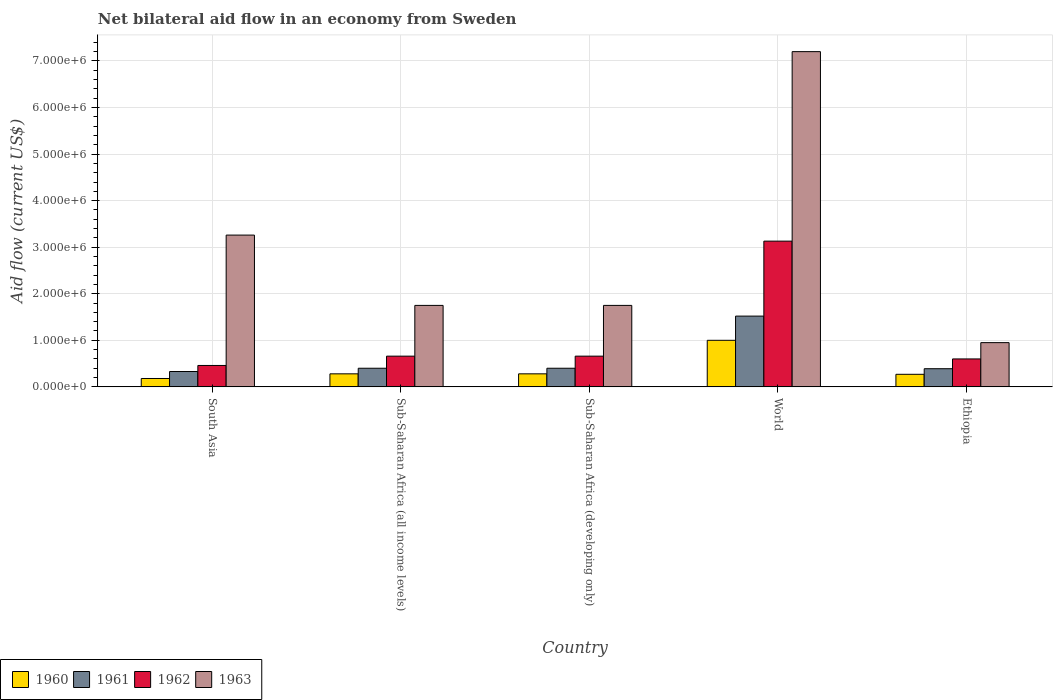How many different coloured bars are there?
Ensure brevity in your answer.  4. How many bars are there on the 2nd tick from the left?
Your response must be concise. 4. How many bars are there on the 5th tick from the right?
Give a very brief answer. 4. What is the label of the 5th group of bars from the left?
Keep it short and to the point. Ethiopia. What is the net bilateral aid flow in 1963 in South Asia?
Your answer should be compact. 3.26e+06. Across all countries, what is the maximum net bilateral aid flow in 1961?
Your answer should be compact. 1.52e+06. In which country was the net bilateral aid flow in 1960 maximum?
Provide a short and direct response. World. In which country was the net bilateral aid flow in 1960 minimum?
Offer a terse response. South Asia. What is the total net bilateral aid flow in 1961 in the graph?
Provide a succinct answer. 3.04e+06. What is the difference between the net bilateral aid flow in 1963 in Ethiopia and that in World?
Ensure brevity in your answer.  -6.25e+06. What is the average net bilateral aid flow in 1963 per country?
Make the answer very short. 2.98e+06. In how many countries, is the net bilateral aid flow in 1963 greater than 3600000 US$?
Your answer should be very brief. 1. What is the ratio of the net bilateral aid flow in 1961 in South Asia to that in World?
Offer a terse response. 0.22. Is the net bilateral aid flow in 1961 in Ethiopia less than that in South Asia?
Offer a terse response. No. Is the difference between the net bilateral aid flow in 1962 in Sub-Saharan Africa (developing only) and World greater than the difference between the net bilateral aid flow in 1960 in Sub-Saharan Africa (developing only) and World?
Ensure brevity in your answer.  No. What is the difference between the highest and the second highest net bilateral aid flow in 1960?
Provide a succinct answer. 7.20e+05. What is the difference between the highest and the lowest net bilateral aid flow in 1962?
Your answer should be very brief. 2.67e+06. How many countries are there in the graph?
Give a very brief answer. 5. What is the difference between two consecutive major ticks on the Y-axis?
Your answer should be very brief. 1.00e+06. Where does the legend appear in the graph?
Keep it short and to the point. Bottom left. How many legend labels are there?
Provide a succinct answer. 4. What is the title of the graph?
Provide a succinct answer. Net bilateral aid flow in an economy from Sweden. Does "1988" appear as one of the legend labels in the graph?
Your response must be concise. No. What is the label or title of the Y-axis?
Offer a terse response. Aid flow (current US$). What is the Aid flow (current US$) in 1960 in South Asia?
Offer a terse response. 1.80e+05. What is the Aid flow (current US$) of 1961 in South Asia?
Provide a succinct answer. 3.30e+05. What is the Aid flow (current US$) of 1962 in South Asia?
Your answer should be compact. 4.60e+05. What is the Aid flow (current US$) of 1963 in South Asia?
Make the answer very short. 3.26e+06. What is the Aid flow (current US$) of 1960 in Sub-Saharan Africa (all income levels)?
Your response must be concise. 2.80e+05. What is the Aid flow (current US$) in 1961 in Sub-Saharan Africa (all income levels)?
Your response must be concise. 4.00e+05. What is the Aid flow (current US$) in 1962 in Sub-Saharan Africa (all income levels)?
Offer a terse response. 6.60e+05. What is the Aid flow (current US$) of 1963 in Sub-Saharan Africa (all income levels)?
Provide a short and direct response. 1.75e+06. What is the Aid flow (current US$) in 1960 in Sub-Saharan Africa (developing only)?
Provide a short and direct response. 2.80e+05. What is the Aid flow (current US$) of 1962 in Sub-Saharan Africa (developing only)?
Your response must be concise. 6.60e+05. What is the Aid flow (current US$) of 1963 in Sub-Saharan Africa (developing only)?
Provide a succinct answer. 1.75e+06. What is the Aid flow (current US$) in 1961 in World?
Give a very brief answer. 1.52e+06. What is the Aid flow (current US$) in 1962 in World?
Your response must be concise. 3.13e+06. What is the Aid flow (current US$) of 1963 in World?
Keep it short and to the point. 7.20e+06. What is the Aid flow (current US$) in 1963 in Ethiopia?
Keep it short and to the point. 9.50e+05. Across all countries, what is the maximum Aid flow (current US$) of 1960?
Your answer should be compact. 1.00e+06. Across all countries, what is the maximum Aid flow (current US$) in 1961?
Give a very brief answer. 1.52e+06. Across all countries, what is the maximum Aid flow (current US$) of 1962?
Offer a very short reply. 3.13e+06. Across all countries, what is the maximum Aid flow (current US$) in 1963?
Give a very brief answer. 7.20e+06. Across all countries, what is the minimum Aid flow (current US$) of 1960?
Give a very brief answer. 1.80e+05. Across all countries, what is the minimum Aid flow (current US$) in 1962?
Make the answer very short. 4.60e+05. Across all countries, what is the minimum Aid flow (current US$) in 1963?
Your answer should be very brief. 9.50e+05. What is the total Aid flow (current US$) of 1960 in the graph?
Ensure brevity in your answer.  2.01e+06. What is the total Aid flow (current US$) in 1961 in the graph?
Keep it short and to the point. 3.04e+06. What is the total Aid flow (current US$) in 1962 in the graph?
Offer a terse response. 5.51e+06. What is the total Aid flow (current US$) in 1963 in the graph?
Ensure brevity in your answer.  1.49e+07. What is the difference between the Aid flow (current US$) in 1960 in South Asia and that in Sub-Saharan Africa (all income levels)?
Your answer should be compact. -1.00e+05. What is the difference between the Aid flow (current US$) of 1963 in South Asia and that in Sub-Saharan Africa (all income levels)?
Give a very brief answer. 1.51e+06. What is the difference between the Aid flow (current US$) in 1961 in South Asia and that in Sub-Saharan Africa (developing only)?
Give a very brief answer. -7.00e+04. What is the difference between the Aid flow (current US$) of 1963 in South Asia and that in Sub-Saharan Africa (developing only)?
Your response must be concise. 1.51e+06. What is the difference between the Aid flow (current US$) of 1960 in South Asia and that in World?
Provide a succinct answer. -8.20e+05. What is the difference between the Aid flow (current US$) of 1961 in South Asia and that in World?
Offer a terse response. -1.19e+06. What is the difference between the Aid flow (current US$) of 1962 in South Asia and that in World?
Give a very brief answer. -2.67e+06. What is the difference between the Aid flow (current US$) in 1963 in South Asia and that in World?
Offer a terse response. -3.94e+06. What is the difference between the Aid flow (current US$) of 1960 in South Asia and that in Ethiopia?
Your answer should be compact. -9.00e+04. What is the difference between the Aid flow (current US$) in 1962 in South Asia and that in Ethiopia?
Provide a succinct answer. -1.40e+05. What is the difference between the Aid flow (current US$) of 1963 in South Asia and that in Ethiopia?
Keep it short and to the point. 2.31e+06. What is the difference between the Aid flow (current US$) in 1960 in Sub-Saharan Africa (all income levels) and that in World?
Offer a very short reply. -7.20e+05. What is the difference between the Aid flow (current US$) of 1961 in Sub-Saharan Africa (all income levels) and that in World?
Ensure brevity in your answer.  -1.12e+06. What is the difference between the Aid flow (current US$) of 1962 in Sub-Saharan Africa (all income levels) and that in World?
Offer a very short reply. -2.47e+06. What is the difference between the Aid flow (current US$) in 1963 in Sub-Saharan Africa (all income levels) and that in World?
Offer a terse response. -5.45e+06. What is the difference between the Aid flow (current US$) of 1960 in Sub-Saharan Africa (all income levels) and that in Ethiopia?
Make the answer very short. 10000. What is the difference between the Aid flow (current US$) in 1962 in Sub-Saharan Africa (all income levels) and that in Ethiopia?
Offer a very short reply. 6.00e+04. What is the difference between the Aid flow (current US$) of 1963 in Sub-Saharan Africa (all income levels) and that in Ethiopia?
Offer a terse response. 8.00e+05. What is the difference between the Aid flow (current US$) of 1960 in Sub-Saharan Africa (developing only) and that in World?
Ensure brevity in your answer.  -7.20e+05. What is the difference between the Aid flow (current US$) in 1961 in Sub-Saharan Africa (developing only) and that in World?
Your response must be concise. -1.12e+06. What is the difference between the Aid flow (current US$) of 1962 in Sub-Saharan Africa (developing only) and that in World?
Your answer should be very brief. -2.47e+06. What is the difference between the Aid flow (current US$) in 1963 in Sub-Saharan Africa (developing only) and that in World?
Your answer should be very brief. -5.45e+06. What is the difference between the Aid flow (current US$) of 1960 in Sub-Saharan Africa (developing only) and that in Ethiopia?
Provide a succinct answer. 10000. What is the difference between the Aid flow (current US$) in 1962 in Sub-Saharan Africa (developing only) and that in Ethiopia?
Provide a short and direct response. 6.00e+04. What is the difference between the Aid flow (current US$) of 1960 in World and that in Ethiopia?
Offer a very short reply. 7.30e+05. What is the difference between the Aid flow (current US$) in 1961 in World and that in Ethiopia?
Ensure brevity in your answer.  1.13e+06. What is the difference between the Aid flow (current US$) in 1962 in World and that in Ethiopia?
Your response must be concise. 2.53e+06. What is the difference between the Aid flow (current US$) in 1963 in World and that in Ethiopia?
Offer a terse response. 6.25e+06. What is the difference between the Aid flow (current US$) in 1960 in South Asia and the Aid flow (current US$) in 1961 in Sub-Saharan Africa (all income levels)?
Provide a succinct answer. -2.20e+05. What is the difference between the Aid flow (current US$) in 1960 in South Asia and the Aid flow (current US$) in 1962 in Sub-Saharan Africa (all income levels)?
Your answer should be very brief. -4.80e+05. What is the difference between the Aid flow (current US$) in 1960 in South Asia and the Aid flow (current US$) in 1963 in Sub-Saharan Africa (all income levels)?
Your response must be concise. -1.57e+06. What is the difference between the Aid flow (current US$) in 1961 in South Asia and the Aid flow (current US$) in 1962 in Sub-Saharan Africa (all income levels)?
Your answer should be compact. -3.30e+05. What is the difference between the Aid flow (current US$) in 1961 in South Asia and the Aid flow (current US$) in 1963 in Sub-Saharan Africa (all income levels)?
Offer a terse response. -1.42e+06. What is the difference between the Aid flow (current US$) in 1962 in South Asia and the Aid flow (current US$) in 1963 in Sub-Saharan Africa (all income levels)?
Your response must be concise. -1.29e+06. What is the difference between the Aid flow (current US$) of 1960 in South Asia and the Aid flow (current US$) of 1961 in Sub-Saharan Africa (developing only)?
Your answer should be compact. -2.20e+05. What is the difference between the Aid flow (current US$) in 1960 in South Asia and the Aid flow (current US$) in 1962 in Sub-Saharan Africa (developing only)?
Your response must be concise. -4.80e+05. What is the difference between the Aid flow (current US$) of 1960 in South Asia and the Aid flow (current US$) of 1963 in Sub-Saharan Africa (developing only)?
Make the answer very short. -1.57e+06. What is the difference between the Aid flow (current US$) in 1961 in South Asia and the Aid flow (current US$) in 1962 in Sub-Saharan Africa (developing only)?
Your answer should be very brief. -3.30e+05. What is the difference between the Aid flow (current US$) of 1961 in South Asia and the Aid flow (current US$) of 1963 in Sub-Saharan Africa (developing only)?
Offer a terse response. -1.42e+06. What is the difference between the Aid flow (current US$) of 1962 in South Asia and the Aid flow (current US$) of 1963 in Sub-Saharan Africa (developing only)?
Provide a succinct answer. -1.29e+06. What is the difference between the Aid flow (current US$) in 1960 in South Asia and the Aid flow (current US$) in 1961 in World?
Offer a very short reply. -1.34e+06. What is the difference between the Aid flow (current US$) of 1960 in South Asia and the Aid flow (current US$) of 1962 in World?
Your answer should be very brief. -2.95e+06. What is the difference between the Aid flow (current US$) in 1960 in South Asia and the Aid flow (current US$) in 1963 in World?
Provide a succinct answer. -7.02e+06. What is the difference between the Aid flow (current US$) of 1961 in South Asia and the Aid flow (current US$) of 1962 in World?
Your answer should be very brief. -2.80e+06. What is the difference between the Aid flow (current US$) in 1961 in South Asia and the Aid flow (current US$) in 1963 in World?
Provide a succinct answer. -6.87e+06. What is the difference between the Aid flow (current US$) of 1962 in South Asia and the Aid flow (current US$) of 1963 in World?
Provide a short and direct response. -6.74e+06. What is the difference between the Aid flow (current US$) in 1960 in South Asia and the Aid flow (current US$) in 1961 in Ethiopia?
Your answer should be very brief. -2.10e+05. What is the difference between the Aid flow (current US$) in 1960 in South Asia and the Aid flow (current US$) in 1962 in Ethiopia?
Provide a succinct answer. -4.20e+05. What is the difference between the Aid flow (current US$) in 1960 in South Asia and the Aid flow (current US$) in 1963 in Ethiopia?
Keep it short and to the point. -7.70e+05. What is the difference between the Aid flow (current US$) of 1961 in South Asia and the Aid flow (current US$) of 1962 in Ethiopia?
Keep it short and to the point. -2.70e+05. What is the difference between the Aid flow (current US$) in 1961 in South Asia and the Aid flow (current US$) in 1963 in Ethiopia?
Provide a short and direct response. -6.20e+05. What is the difference between the Aid flow (current US$) in 1962 in South Asia and the Aid flow (current US$) in 1963 in Ethiopia?
Provide a short and direct response. -4.90e+05. What is the difference between the Aid flow (current US$) of 1960 in Sub-Saharan Africa (all income levels) and the Aid flow (current US$) of 1962 in Sub-Saharan Africa (developing only)?
Ensure brevity in your answer.  -3.80e+05. What is the difference between the Aid flow (current US$) in 1960 in Sub-Saharan Africa (all income levels) and the Aid flow (current US$) in 1963 in Sub-Saharan Africa (developing only)?
Give a very brief answer. -1.47e+06. What is the difference between the Aid flow (current US$) in 1961 in Sub-Saharan Africa (all income levels) and the Aid flow (current US$) in 1962 in Sub-Saharan Africa (developing only)?
Offer a very short reply. -2.60e+05. What is the difference between the Aid flow (current US$) in 1961 in Sub-Saharan Africa (all income levels) and the Aid flow (current US$) in 1963 in Sub-Saharan Africa (developing only)?
Ensure brevity in your answer.  -1.35e+06. What is the difference between the Aid flow (current US$) of 1962 in Sub-Saharan Africa (all income levels) and the Aid flow (current US$) of 1963 in Sub-Saharan Africa (developing only)?
Give a very brief answer. -1.09e+06. What is the difference between the Aid flow (current US$) of 1960 in Sub-Saharan Africa (all income levels) and the Aid flow (current US$) of 1961 in World?
Offer a terse response. -1.24e+06. What is the difference between the Aid flow (current US$) in 1960 in Sub-Saharan Africa (all income levels) and the Aid flow (current US$) in 1962 in World?
Provide a succinct answer. -2.85e+06. What is the difference between the Aid flow (current US$) in 1960 in Sub-Saharan Africa (all income levels) and the Aid flow (current US$) in 1963 in World?
Offer a very short reply. -6.92e+06. What is the difference between the Aid flow (current US$) in 1961 in Sub-Saharan Africa (all income levels) and the Aid flow (current US$) in 1962 in World?
Provide a succinct answer. -2.73e+06. What is the difference between the Aid flow (current US$) in 1961 in Sub-Saharan Africa (all income levels) and the Aid flow (current US$) in 1963 in World?
Provide a succinct answer. -6.80e+06. What is the difference between the Aid flow (current US$) in 1962 in Sub-Saharan Africa (all income levels) and the Aid flow (current US$) in 1963 in World?
Provide a succinct answer. -6.54e+06. What is the difference between the Aid flow (current US$) in 1960 in Sub-Saharan Africa (all income levels) and the Aid flow (current US$) in 1961 in Ethiopia?
Provide a succinct answer. -1.10e+05. What is the difference between the Aid flow (current US$) of 1960 in Sub-Saharan Africa (all income levels) and the Aid flow (current US$) of 1962 in Ethiopia?
Provide a succinct answer. -3.20e+05. What is the difference between the Aid flow (current US$) of 1960 in Sub-Saharan Africa (all income levels) and the Aid flow (current US$) of 1963 in Ethiopia?
Your answer should be very brief. -6.70e+05. What is the difference between the Aid flow (current US$) of 1961 in Sub-Saharan Africa (all income levels) and the Aid flow (current US$) of 1962 in Ethiopia?
Keep it short and to the point. -2.00e+05. What is the difference between the Aid flow (current US$) in 1961 in Sub-Saharan Africa (all income levels) and the Aid flow (current US$) in 1963 in Ethiopia?
Your answer should be compact. -5.50e+05. What is the difference between the Aid flow (current US$) in 1960 in Sub-Saharan Africa (developing only) and the Aid flow (current US$) in 1961 in World?
Provide a succinct answer. -1.24e+06. What is the difference between the Aid flow (current US$) of 1960 in Sub-Saharan Africa (developing only) and the Aid flow (current US$) of 1962 in World?
Ensure brevity in your answer.  -2.85e+06. What is the difference between the Aid flow (current US$) in 1960 in Sub-Saharan Africa (developing only) and the Aid flow (current US$) in 1963 in World?
Give a very brief answer. -6.92e+06. What is the difference between the Aid flow (current US$) in 1961 in Sub-Saharan Africa (developing only) and the Aid flow (current US$) in 1962 in World?
Your answer should be very brief. -2.73e+06. What is the difference between the Aid flow (current US$) of 1961 in Sub-Saharan Africa (developing only) and the Aid flow (current US$) of 1963 in World?
Your answer should be very brief. -6.80e+06. What is the difference between the Aid flow (current US$) of 1962 in Sub-Saharan Africa (developing only) and the Aid flow (current US$) of 1963 in World?
Make the answer very short. -6.54e+06. What is the difference between the Aid flow (current US$) in 1960 in Sub-Saharan Africa (developing only) and the Aid flow (current US$) in 1961 in Ethiopia?
Keep it short and to the point. -1.10e+05. What is the difference between the Aid flow (current US$) in 1960 in Sub-Saharan Africa (developing only) and the Aid flow (current US$) in 1962 in Ethiopia?
Provide a succinct answer. -3.20e+05. What is the difference between the Aid flow (current US$) of 1960 in Sub-Saharan Africa (developing only) and the Aid flow (current US$) of 1963 in Ethiopia?
Give a very brief answer. -6.70e+05. What is the difference between the Aid flow (current US$) of 1961 in Sub-Saharan Africa (developing only) and the Aid flow (current US$) of 1963 in Ethiopia?
Make the answer very short. -5.50e+05. What is the difference between the Aid flow (current US$) of 1962 in Sub-Saharan Africa (developing only) and the Aid flow (current US$) of 1963 in Ethiopia?
Make the answer very short. -2.90e+05. What is the difference between the Aid flow (current US$) in 1960 in World and the Aid flow (current US$) in 1961 in Ethiopia?
Your answer should be very brief. 6.10e+05. What is the difference between the Aid flow (current US$) in 1961 in World and the Aid flow (current US$) in 1962 in Ethiopia?
Provide a succinct answer. 9.20e+05. What is the difference between the Aid flow (current US$) in 1961 in World and the Aid flow (current US$) in 1963 in Ethiopia?
Offer a terse response. 5.70e+05. What is the difference between the Aid flow (current US$) in 1962 in World and the Aid flow (current US$) in 1963 in Ethiopia?
Offer a very short reply. 2.18e+06. What is the average Aid flow (current US$) of 1960 per country?
Give a very brief answer. 4.02e+05. What is the average Aid flow (current US$) of 1961 per country?
Offer a very short reply. 6.08e+05. What is the average Aid flow (current US$) in 1962 per country?
Offer a very short reply. 1.10e+06. What is the average Aid flow (current US$) of 1963 per country?
Offer a very short reply. 2.98e+06. What is the difference between the Aid flow (current US$) of 1960 and Aid flow (current US$) of 1961 in South Asia?
Provide a short and direct response. -1.50e+05. What is the difference between the Aid flow (current US$) of 1960 and Aid flow (current US$) of 1962 in South Asia?
Offer a terse response. -2.80e+05. What is the difference between the Aid flow (current US$) of 1960 and Aid flow (current US$) of 1963 in South Asia?
Your response must be concise. -3.08e+06. What is the difference between the Aid flow (current US$) of 1961 and Aid flow (current US$) of 1963 in South Asia?
Offer a terse response. -2.93e+06. What is the difference between the Aid flow (current US$) of 1962 and Aid flow (current US$) of 1963 in South Asia?
Make the answer very short. -2.80e+06. What is the difference between the Aid flow (current US$) in 1960 and Aid flow (current US$) in 1961 in Sub-Saharan Africa (all income levels)?
Ensure brevity in your answer.  -1.20e+05. What is the difference between the Aid flow (current US$) of 1960 and Aid flow (current US$) of 1962 in Sub-Saharan Africa (all income levels)?
Your answer should be very brief. -3.80e+05. What is the difference between the Aid flow (current US$) of 1960 and Aid flow (current US$) of 1963 in Sub-Saharan Africa (all income levels)?
Your response must be concise. -1.47e+06. What is the difference between the Aid flow (current US$) in 1961 and Aid flow (current US$) in 1962 in Sub-Saharan Africa (all income levels)?
Keep it short and to the point. -2.60e+05. What is the difference between the Aid flow (current US$) in 1961 and Aid flow (current US$) in 1963 in Sub-Saharan Africa (all income levels)?
Provide a succinct answer. -1.35e+06. What is the difference between the Aid flow (current US$) in 1962 and Aid flow (current US$) in 1963 in Sub-Saharan Africa (all income levels)?
Offer a terse response. -1.09e+06. What is the difference between the Aid flow (current US$) in 1960 and Aid flow (current US$) in 1961 in Sub-Saharan Africa (developing only)?
Give a very brief answer. -1.20e+05. What is the difference between the Aid flow (current US$) of 1960 and Aid flow (current US$) of 1962 in Sub-Saharan Africa (developing only)?
Offer a terse response. -3.80e+05. What is the difference between the Aid flow (current US$) of 1960 and Aid flow (current US$) of 1963 in Sub-Saharan Africa (developing only)?
Your answer should be very brief. -1.47e+06. What is the difference between the Aid flow (current US$) in 1961 and Aid flow (current US$) in 1962 in Sub-Saharan Africa (developing only)?
Offer a very short reply. -2.60e+05. What is the difference between the Aid flow (current US$) of 1961 and Aid flow (current US$) of 1963 in Sub-Saharan Africa (developing only)?
Your answer should be very brief. -1.35e+06. What is the difference between the Aid flow (current US$) in 1962 and Aid flow (current US$) in 1963 in Sub-Saharan Africa (developing only)?
Make the answer very short. -1.09e+06. What is the difference between the Aid flow (current US$) of 1960 and Aid flow (current US$) of 1961 in World?
Offer a very short reply. -5.20e+05. What is the difference between the Aid flow (current US$) in 1960 and Aid flow (current US$) in 1962 in World?
Your response must be concise. -2.13e+06. What is the difference between the Aid flow (current US$) of 1960 and Aid flow (current US$) of 1963 in World?
Give a very brief answer. -6.20e+06. What is the difference between the Aid flow (current US$) of 1961 and Aid flow (current US$) of 1962 in World?
Keep it short and to the point. -1.61e+06. What is the difference between the Aid flow (current US$) of 1961 and Aid flow (current US$) of 1963 in World?
Your answer should be compact. -5.68e+06. What is the difference between the Aid flow (current US$) in 1962 and Aid flow (current US$) in 1963 in World?
Keep it short and to the point. -4.07e+06. What is the difference between the Aid flow (current US$) in 1960 and Aid flow (current US$) in 1962 in Ethiopia?
Keep it short and to the point. -3.30e+05. What is the difference between the Aid flow (current US$) of 1960 and Aid flow (current US$) of 1963 in Ethiopia?
Your answer should be very brief. -6.80e+05. What is the difference between the Aid flow (current US$) of 1961 and Aid flow (current US$) of 1962 in Ethiopia?
Offer a very short reply. -2.10e+05. What is the difference between the Aid flow (current US$) in 1961 and Aid flow (current US$) in 1963 in Ethiopia?
Your response must be concise. -5.60e+05. What is the difference between the Aid flow (current US$) in 1962 and Aid flow (current US$) in 1963 in Ethiopia?
Your answer should be very brief. -3.50e+05. What is the ratio of the Aid flow (current US$) of 1960 in South Asia to that in Sub-Saharan Africa (all income levels)?
Your response must be concise. 0.64. What is the ratio of the Aid flow (current US$) in 1961 in South Asia to that in Sub-Saharan Africa (all income levels)?
Provide a short and direct response. 0.82. What is the ratio of the Aid flow (current US$) in 1962 in South Asia to that in Sub-Saharan Africa (all income levels)?
Keep it short and to the point. 0.7. What is the ratio of the Aid flow (current US$) in 1963 in South Asia to that in Sub-Saharan Africa (all income levels)?
Give a very brief answer. 1.86. What is the ratio of the Aid flow (current US$) in 1960 in South Asia to that in Sub-Saharan Africa (developing only)?
Provide a succinct answer. 0.64. What is the ratio of the Aid flow (current US$) in 1961 in South Asia to that in Sub-Saharan Africa (developing only)?
Keep it short and to the point. 0.82. What is the ratio of the Aid flow (current US$) in 1962 in South Asia to that in Sub-Saharan Africa (developing only)?
Offer a very short reply. 0.7. What is the ratio of the Aid flow (current US$) in 1963 in South Asia to that in Sub-Saharan Africa (developing only)?
Keep it short and to the point. 1.86. What is the ratio of the Aid flow (current US$) of 1960 in South Asia to that in World?
Make the answer very short. 0.18. What is the ratio of the Aid flow (current US$) in 1961 in South Asia to that in World?
Give a very brief answer. 0.22. What is the ratio of the Aid flow (current US$) of 1962 in South Asia to that in World?
Your response must be concise. 0.15. What is the ratio of the Aid flow (current US$) of 1963 in South Asia to that in World?
Give a very brief answer. 0.45. What is the ratio of the Aid flow (current US$) in 1961 in South Asia to that in Ethiopia?
Give a very brief answer. 0.85. What is the ratio of the Aid flow (current US$) of 1962 in South Asia to that in Ethiopia?
Offer a very short reply. 0.77. What is the ratio of the Aid flow (current US$) in 1963 in South Asia to that in Ethiopia?
Your answer should be very brief. 3.43. What is the ratio of the Aid flow (current US$) in 1962 in Sub-Saharan Africa (all income levels) to that in Sub-Saharan Africa (developing only)?
Provide a short and direct response. 1. What is the ratio of the Aid flow (current US$) in 1963 in Sub-Saharan Africa (all income levels) to that in Sub-Saharan Africa (developing only)?
Your response must be concise. 1. What is the ratio of the Aid flow (current US$) in 1960 in Sub-Saharan Africa (all income levels) to that in World?
Your answer should be very brief. 0.28. What is the ratio of the Aid flow (current US$) of 1961 in Sub-Saharan Africa (all income levels) to that in World?
Ensure brevity in your answer.  0.26. What is the ratio of the Aid flow (current US$) in 1962 in Sub-Saharan Africa (all income levels) to that in World?
Give a very brief answer. 0.21. What is the ratio of the Aid flow (current US$) in 1963 in Sub-Saharan Africa (all income levels) to that in World?
Your response must be concise. 0.24. What is the ratio of the Aid flow (current US$) in 1960 in Sub-Saharan Africa (all income levels) to that in Ethiopia?
Make the answer very short. 1.04. What is the ratio of the Aid flow (current US$) in 1961 in Sub-Saharan Africa (all income levels) to that in Ethiopia?
Give a very brief answer. 1.03. What is the ratio of the Aid flow (current US$) of 1963 in Sub-Saharan Africa (all income levels) to that in Ethiopia?
Give a very brief answer. 1.84. What is the ratio of the Aid flow (current US$) in 1960 in Sub-Saharan Africa (developing only) to that in World?
Offer a very short reply. 0.28. What is the ratio of the Aid flow (current US$) in 1961 in Sub-Saharan Africa (developing only) to that in World?
Your answer should be compact. 0.26. What is the ratio of the Aid flow (current US$) in 1962 in Sub-Saharan Africa (developing only) to that in World?
Give a very brief answer. 0.21. What is the ratio of the Aid flow (current US$) of 1963 in Sub-Saharan Africa (developing only) to that in World?
Give a very brief answer. 0.24. What is the ratio of the Aid flow (current US$) of 1961 in Sub-Saharan Africa (developing only) to that in Ethiopia?
Your answer should be very brief. 1.03. What is the ratio of the Aid flow (current US$) in 1962 in Sub-Saharan Africa (developing only) to that in Ethiopia?
Provide a succinct answer. 1.1. What is the ratio of the Aid flow (current US$) of 1963 in Sub-Saharan Africa (developing only) to that in Ethiopia?
Your answer should be compact. 1.84. What is the ratio of the Aid flow (current US$) in 1960 in World to that in Ethiopia?
Your response must be concise. 3.7. What is the ratio of the Aid flow (current US$) in 1961 in World to that in Ethiopia?
Give a very brief answer. 3.9. What is the ratio of the Aid flow (current US$) in 1962 in World to that in Ethiopia?
Provide a succinct answer. 5.22. What is the ratio of the Aid flow (current US$) of 1963 in World to that in Ethiopia?
Offer a very short reply. 7.58. What is the difference between the highest and the second highest Aid flow (current US$) of 1960?
Keep it short and to the point. 7.20e+05. What is the difference between the highest and the second highest Aid flow (current US$) of 1961?
Offer a very short reply. 1.12e+06. What is the difference between the highest and the second highest Aid flow (current US$) of 1962?
Give a very brief answer. 2.47e+06. What is the difference between the highest and the second highest Aid flow (current US$) in 1963?
Offer a terse response. 3.94e+06. What is the difference between the highest and the lowest Aid flow (current US$) of 1960?
Give a very brief answer. 8.20e+05. What is the difference between the highest and the lowest Aid flow (current US$) of 1961?
Provide a short and direct response. 1.19e+06. What is the difference between the highest and the lowest Aid flow (current US$) in 1962?
Ensure brevity in your answer.  2.67e+06. What is the difference between the highest and the lowest Aid flow (current US$) in 1963?
Keep it short and to the point. 6.25e+06. 